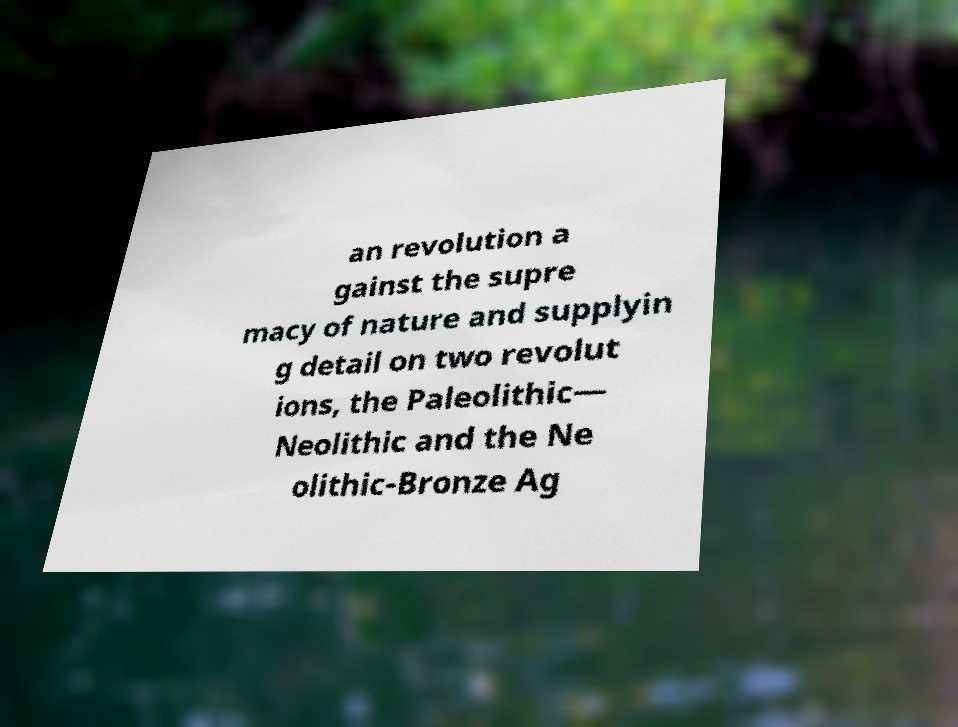Could you extract and type out the text from this image? an revolution a gainst the supre macy of nature and supplyin g detail on two revolut ions, the Paleolithic— Neolithic and the Ne olithic-Bronze Ag 